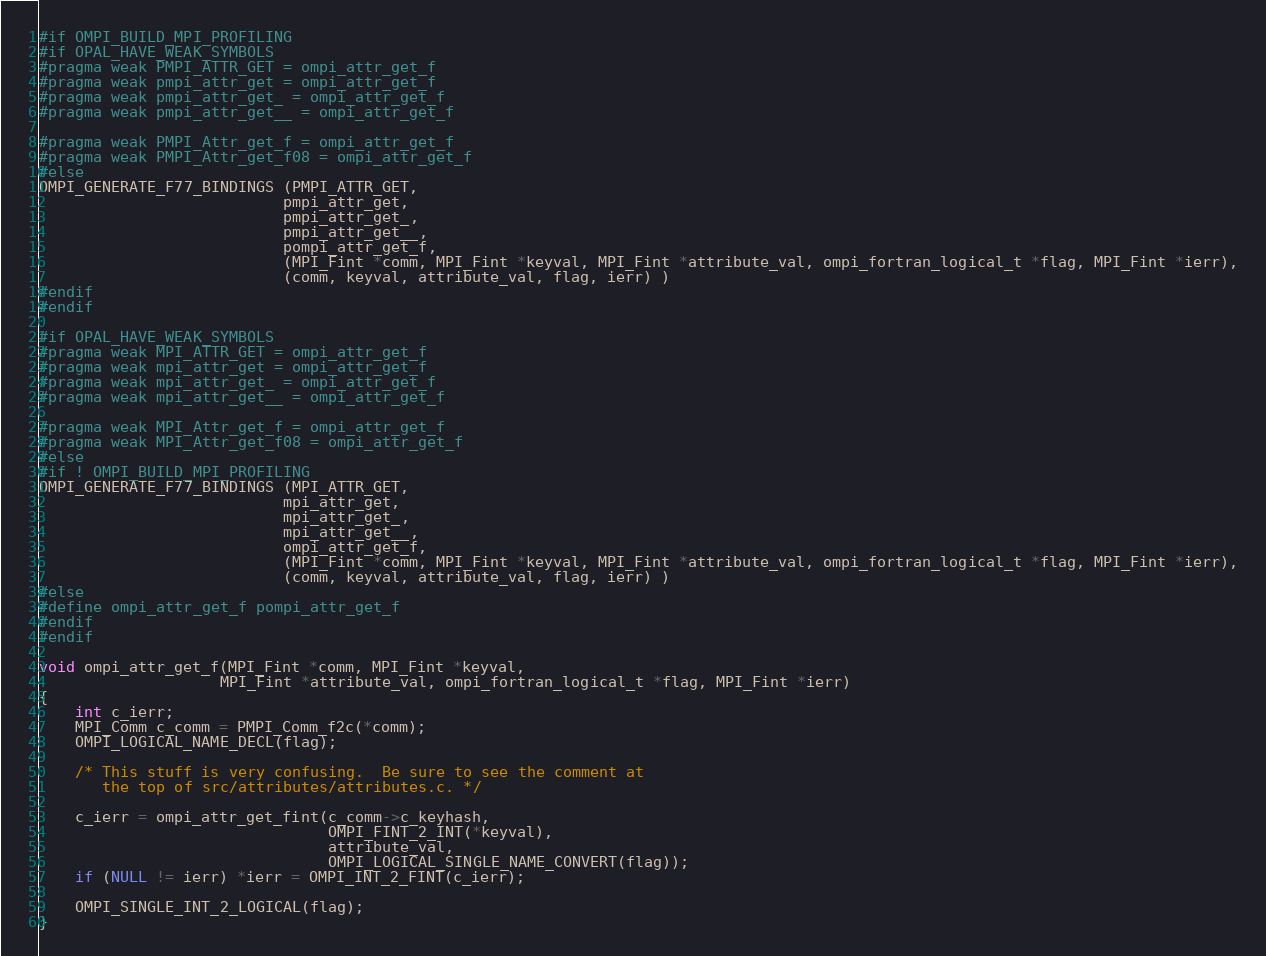<code> <loc_0><loc_0><loc_500><loc_500><_C_>#if OMPI_BUILD_MPI_PROFILING
#if OPAL_HAVE_WEAK_SYMBOLS
#pragma weak PMPI_ATTR_GET = ompi_attr_get_f
#pragma weak pmpi_attr_get = ompi_attr_get_f
#pragma weak pmpi_attr_get_ = ompi_attr_get_f
#pragma weak pmpi_attr_get__ = ompi_attr_get_f

#pragma weak PMPI_Attr_get_f = ompi_attr_get_f
#pragma weak PMPI_Attr_get_f08 = ompi_attr_get_f
#else
OMPI_GENERATE_F77_BINDINGS (PMPI_ATTR_GET,
                           pmpi_attr_get,
                           pmpi_attr_get_,
                           pmpi_attr_get__,
                           pompi_attr_get_f,
                           (MPI_Fint *comm, MPI_Fint *keyval, MPI_Fint *attribute_val, ompi_fortran_logical_t *flag, MPI_Fint *ierr),
                           (comm, keyval, attribute_val, flag, ierr) )
#endif
#endif

#if OPAL_HAVE_WEAK_SYMBOLS
#pragma weak MPI_ATTR_GET = ompi_attr_get_f
#pragma weak mpi_attr_get = ompi_attr_get_f
#pragma weak mpi_attr_get_ = ompi_attr_get_f
#pragma weak mpi_attr_get__ = ompi_attr_get_f

#pragma weak MPI_Attr_get_f = ompi_attr_get_f
#pragma weak MPI_Attr_get_f08 = ompi_attr_get_f
#else
#if ! OMPI_BUILD_MPI_PROFILING
OMPI_GENERATE_F77_BINDINGS (MPI_ATTR_GET,
                           mpi_attr_get,
                           mpi_attr_get_,
                           mpi_attr_get__,
                           ompi_attr_get_f,
                           (MPI_Fint *comm, MPI_Fint *keyval, MPI_Fint *attribute_val, ompi_fortran_logical_t *flag, MPI_Fint *ierr),
                           (comm, keyval, attribute_val, flag, ierr) )
#else
#define ompi_attr_get_f pompi_attr_get_f
#endif
#endif

void ompi_attr_get_f(MPI_Fint *comm, MPI_Fint *keyval,
                    MPI_Fint *attribute_val, ompi_fortran_logical_t *flag, MPI_Fint *ierr)
{
    int c_ierr;
    MPI_Comm c_comm = PMPI_Comm_f2c(*comm);
    OMPI_LOGICAL_NAME_DECL(flag);

    /* This stuff is very confusing.  Be sure to see the comment at
       the top of src/attributes/attributes.c. */

    c_ierr = ompi_attr_get_fint(c_comm->c_keyhash,
                                OMPI_FINT_2_INT(*keyval),
                                attribute_val,
                                OMPI_LOGICAL_SINGLE_NAME_CONVERT(flag));
    if (NULL != ierr) *ierr = OMPI_INT_2_FINT(c_ierr);

    OMPI_SINGLE_INT_2_LOGICAL(flag);
}
</code> 